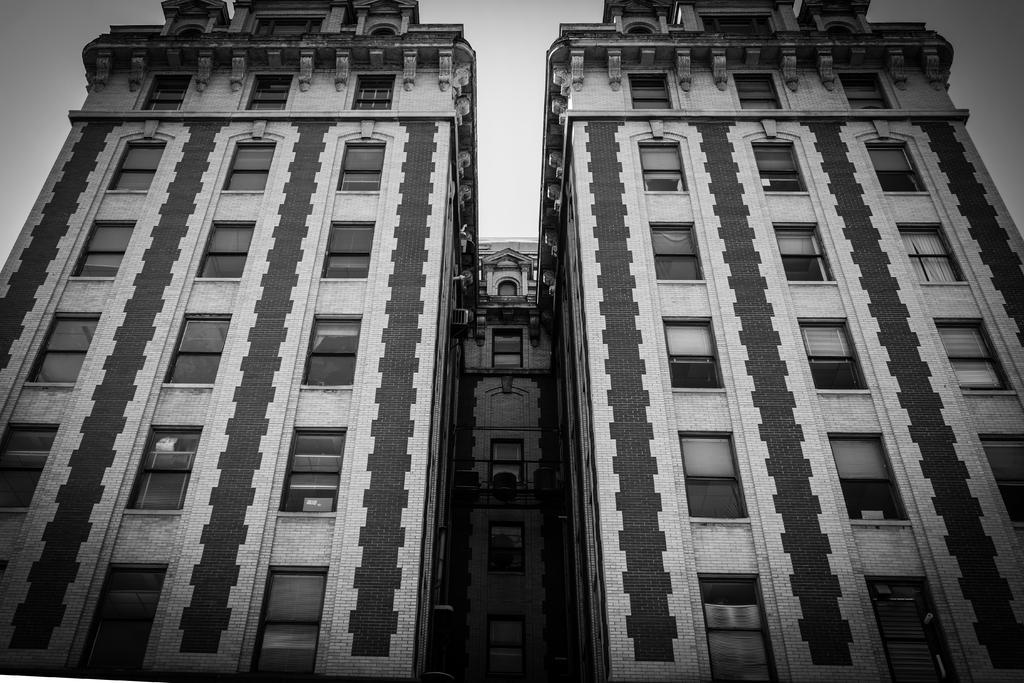Describe this image in one or two sentences. In this black and white picture there are buildings. There are windows to the walls of the buildings. At the top there is the sky. 